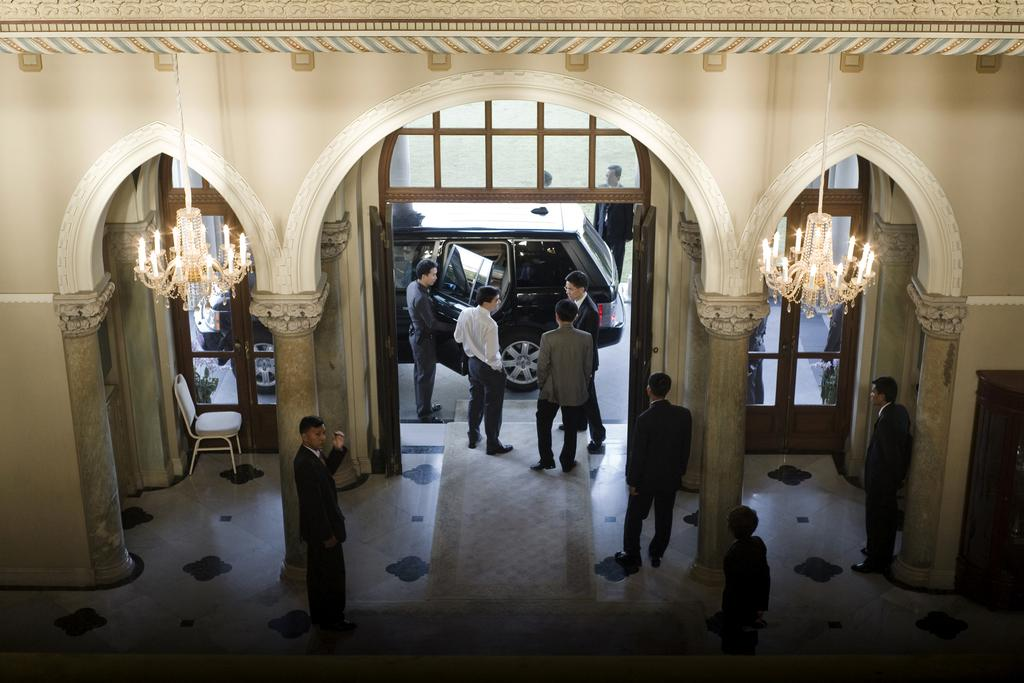Where was the image taken? The image was taken inside a building. What can be seen in the center of the image? There are persons standing in the center of the image. What type of vehicle is present in the image? There is a car in the image. What type of furniture is present in the image? There is a chair in the image. How many grapes are on the chair in the image? There are no grapes present in the image; it only features a car and a chair. 